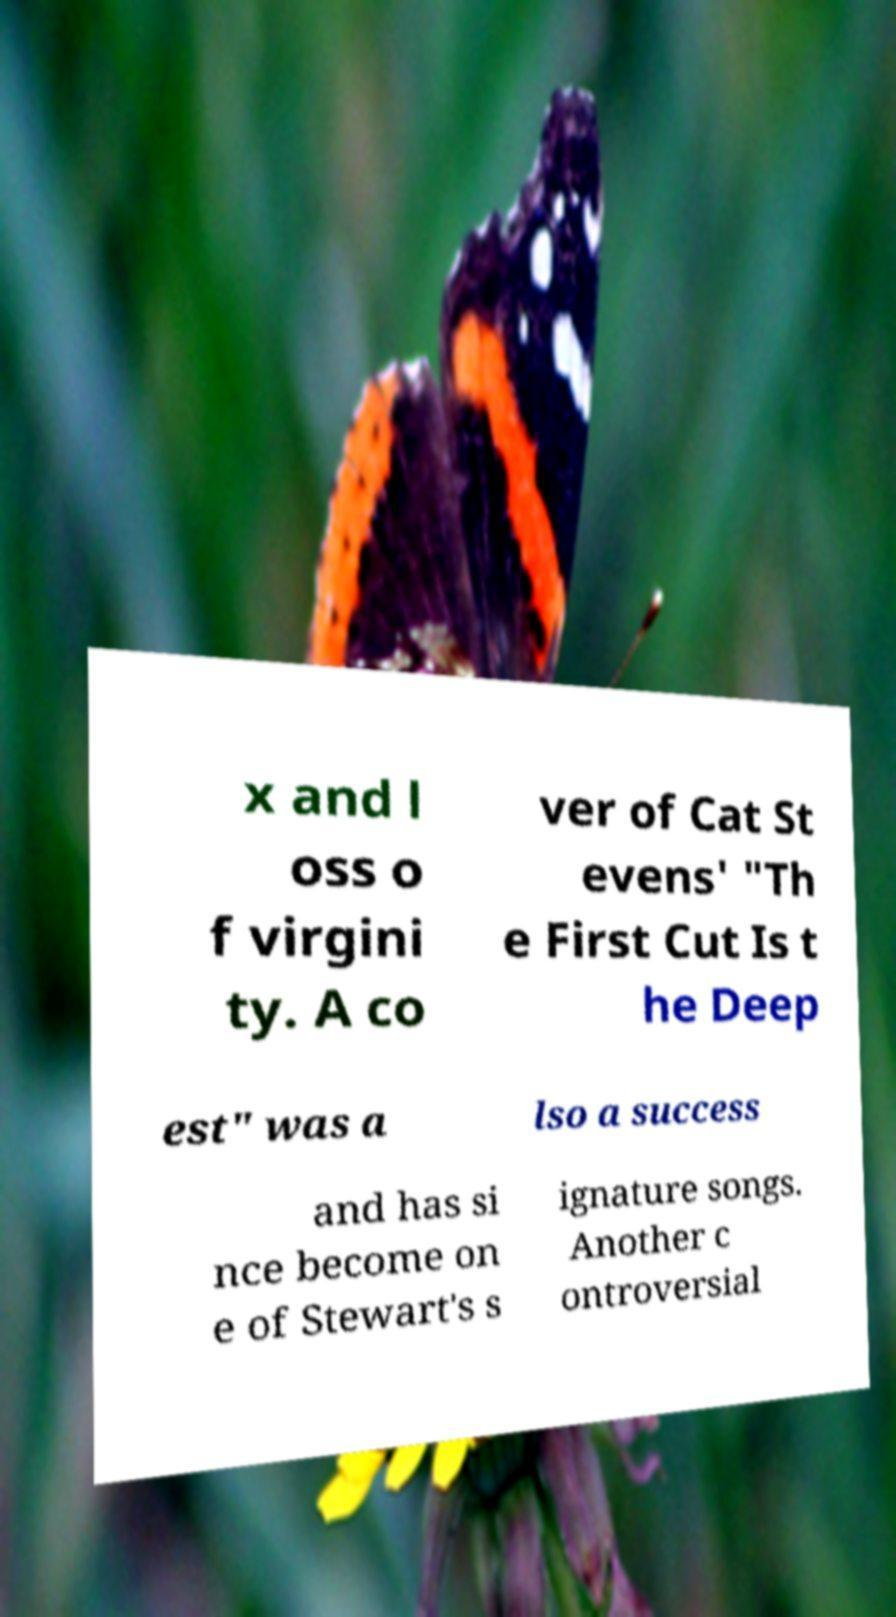Could you assist in decoding the text presented in this image and type it out clearly? x and l oss o f virgini ty. A co ver of Cat St evens' "Th e First Cut Is t he Deep est" was a lso a success and has si nce become on e of Stewart's s ignature songs. Another c ontroversial 